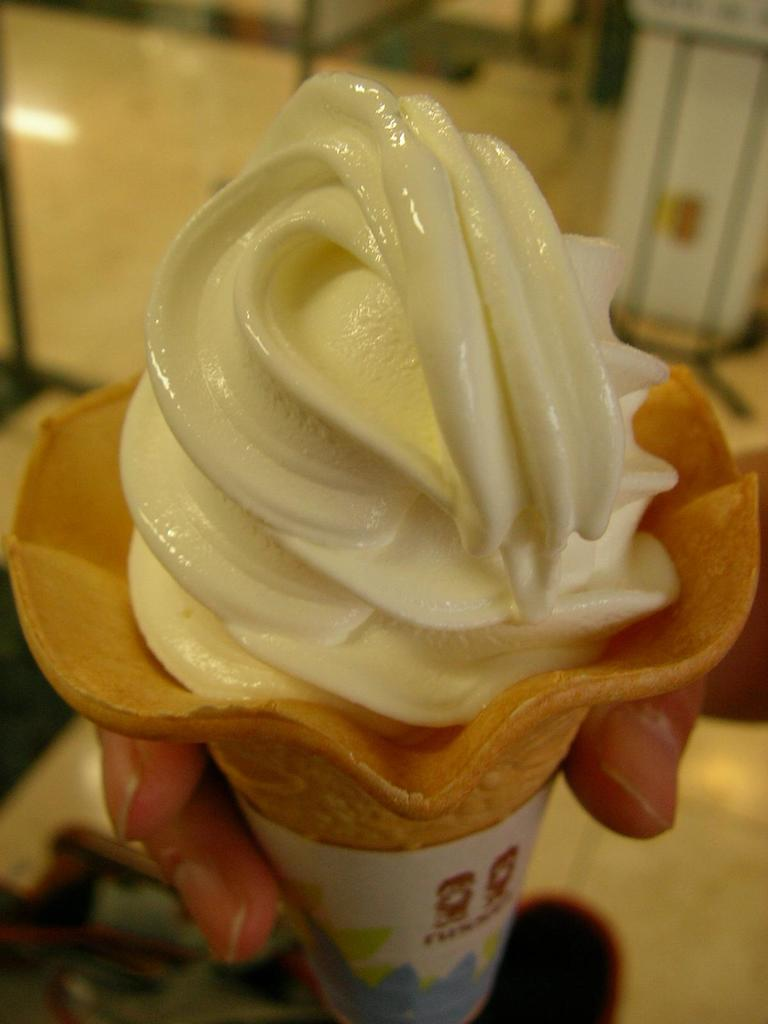Who is the main subject in the image? There is a person in the image. What is the person holding in the image? The person is holding an ice cream. Can you describe the background of the image? There are objects in the background of the image. What advice does the person's mother give them in the image? There is no mention of a mother or any advice being given in the image. 